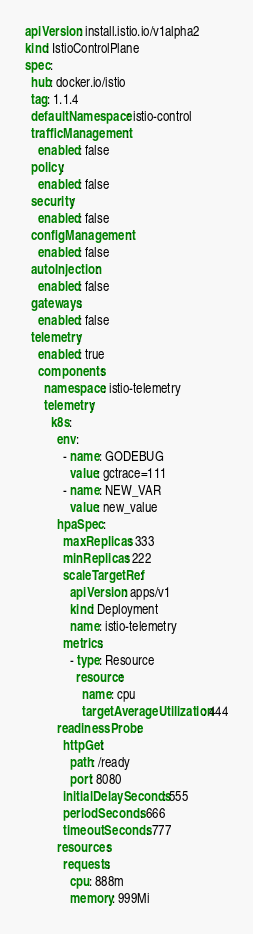Convert code to text. <code><loc_0><loc_0><loc_500><loc_500><_YAML_>apiVersion: install.istio.io/v1alpha2
kind: IstioControlPlane
spec:
  hub: docker.io/istio
  tag: 1.1.4
  defaultNamespace: istio-control
  trafficManagement:
    enabled: false
  policy:
    enabled: false
  security:
    enabled: false
  configManagement:
    enabled: false
  autoInjection:
    enabled: false
  gateways:
    enabled: false
  telemetry:
    enabled: true
    components:
      namespace: istio-telemetry
      telemetry:
        k8s:
          env:
            - name: GODEBUG
              value: gctrace=111
            - name: NEW_VAR
              value: new_value
          hpaSpec:
            maxReplicas: 333
            minReplicas: 222
            scaleTargetRef:
              apiVersion: apps/v1
              kind: Deployment
              name: istio-telemetry
            metrics:
              - type: Resource
                resource:
                  name: cpu
                  targetAverageUtilization: 444
          readinessProbe:
            httpGet:
              path: /ready
              port: 8080
            initialDelaySeconds: 555
            periodSeconds: 666
            timeoutSeconds: 777
          resources:
            requests:
              cpu: 888m
              memory: 999Mi
</code> 